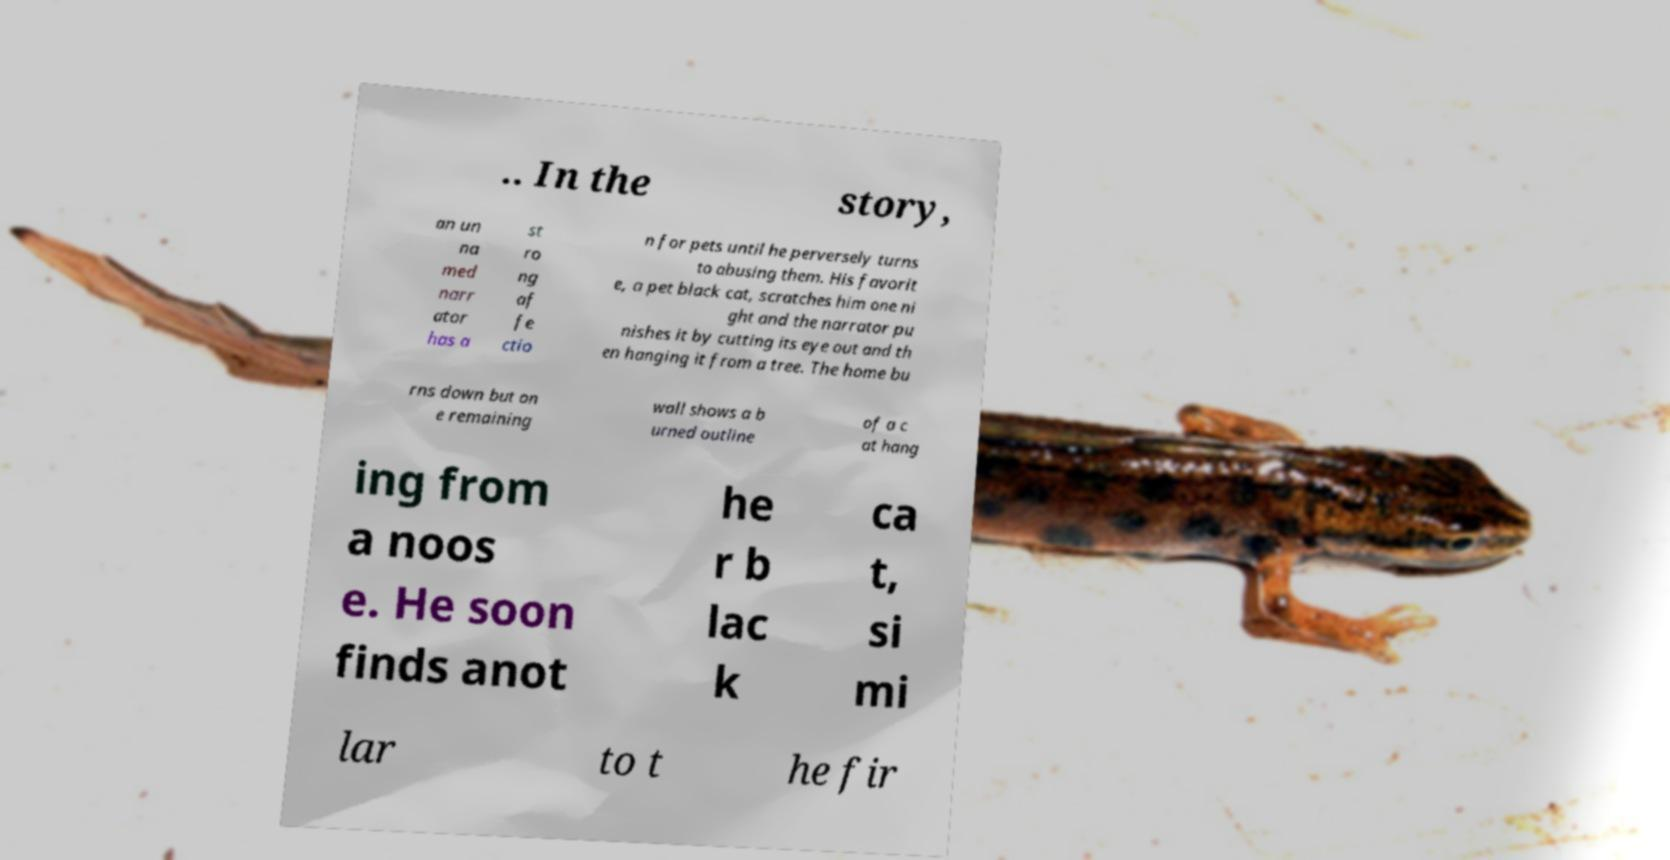I need the written content from this picture converted into text. Can you do that? .. In the story, an un na med narr ator has a st ro ng af fe ctio n for pets until he perversely turns to abusing them. His favorit e, a pet black cat, scratches him one ni ght and the narrator pu nishes it by cutting its eye out and th en hanging it from a tree. The home bu rns down but on e remaining wall shows a b urned outline of a c at hang ing from a noos e. He soon finds anot he r b lac k ca t, si mi lar to t he fir 